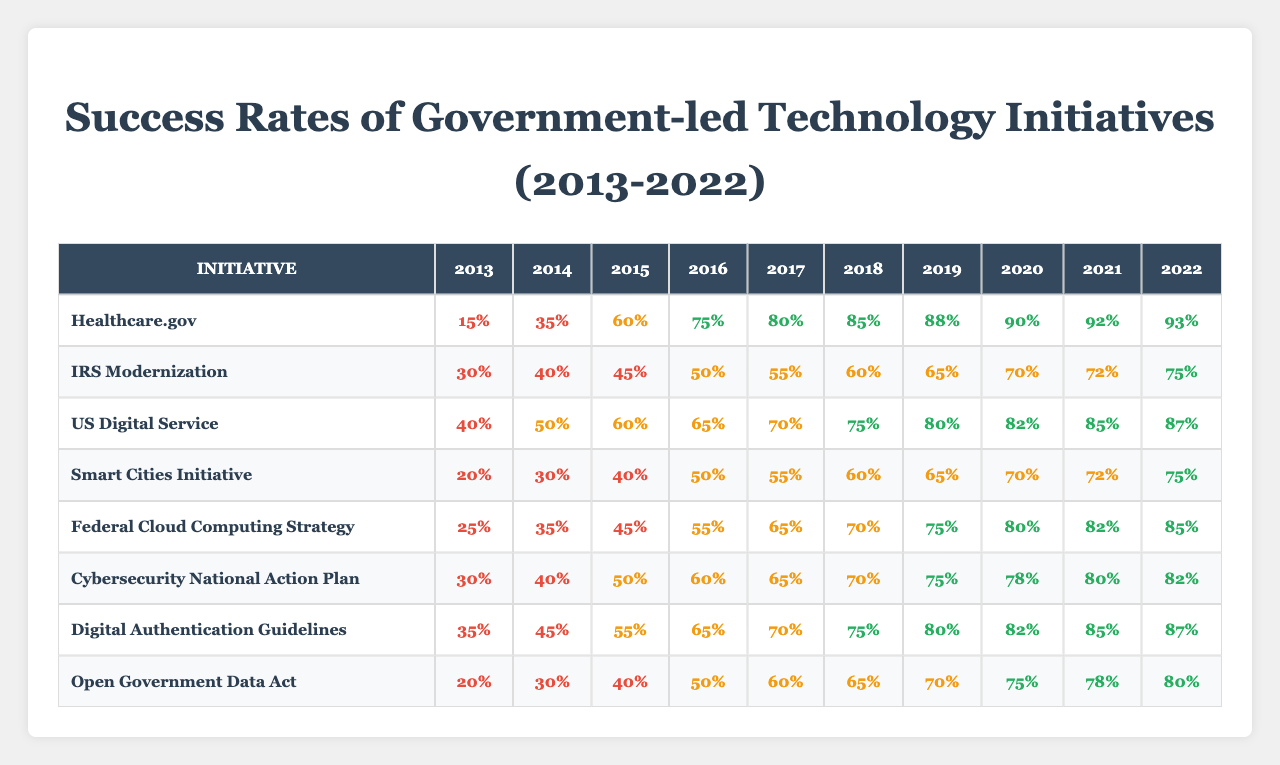What was the success rate of the IRS Modernization initiative in 2015? The table shows the success rate for IRS Modernization in 2015, which is clearly listed as 45%.
Answer: 45% Which initiative had the highest success rate in 2022? According to the table, Healthcare.gov has the highest success rate in 2022 at 93%.
Answer: 93% What is the average success rate of the US Digital Service from 2013 to 2022? To find the average, add all the success rates: (40 + 50 + 60 + 65 + 70 + 75 + 80 + 82 + 85 + 87) =  782. There are 10 data points, so the average is 782 / 10 = 78.2.
Answer: 78.2 Did the Smart Cities Initiative achieve a success rate of 100% in any year? A review of the success rates for the Smart Cities Initiative shows that it did not reach 100% in any year listed.
Answer: No What was the improvement in success rate for the Cybersecurity National Action Plan from 2013 to 2022? The success rate in 2013 was 30%, and in 2022 it rose to 82%. The improvement is calculated as 82% - 30% = 52%.
Answer: 52% Compare the success rates of the Federal Cloud Computing Strategy and the Digital Authentication Guidelines in 2018. Which had a higher success rate? In 2018, the Federal Cloud Computing Strategy had a success rate of 70%, while the Digital Authentication Guidelines had a success rate of 75%. Since 75% is greater than 70%, the Digital Authentication Guidelines had the higher success rate.
Answer: Digital Authentication Guidelines What is the trend in success rates for Open Government Data Act over the decade? The rates increased from 20% in 2013 to 80% in 2022, showing a consistent upward trend through the years.
Answer: Upward trend What was the median success rate for all initiatives in 2019? First, we list the success rates for 2019: [90, 70, 80, 65, 75, 75, 80, 70], which when sorted gives us [65, 70, 70, 75, 75, 80, 80, 90]. The median, for 8 values, is the average of the 4th and 5th values: (75 + 75) / 2 = 75.
Answer: 75 Which initiative consistently improved its success rate every year from 2013 to 2022? Checking each initiative's success rates reveals that Healthcare.gov shows consistent improvement from 15% in 2013 to 93% in 2022.
Answer: Healthcare.gov What was the overall success rate for the Digital Authentication Guidelines in the last three years of the decade? The success rates for the last three years (2020, 2021, 2022) are 82%, 85%, and 87%. To find the overall success rate, calculate the average: (82 + 85 + 87) / 3 = 84.67.
Answer: 84.67 Is the success rate of the Smart Cities Initiative higher than that of the IRS Modernization in 2016? The Smart Cities Initiative had a success rate of 50% in 2016, while IRS Modernization's rate was 50% as well. Therefore, they are equal and neither is higher.
Answer: No 